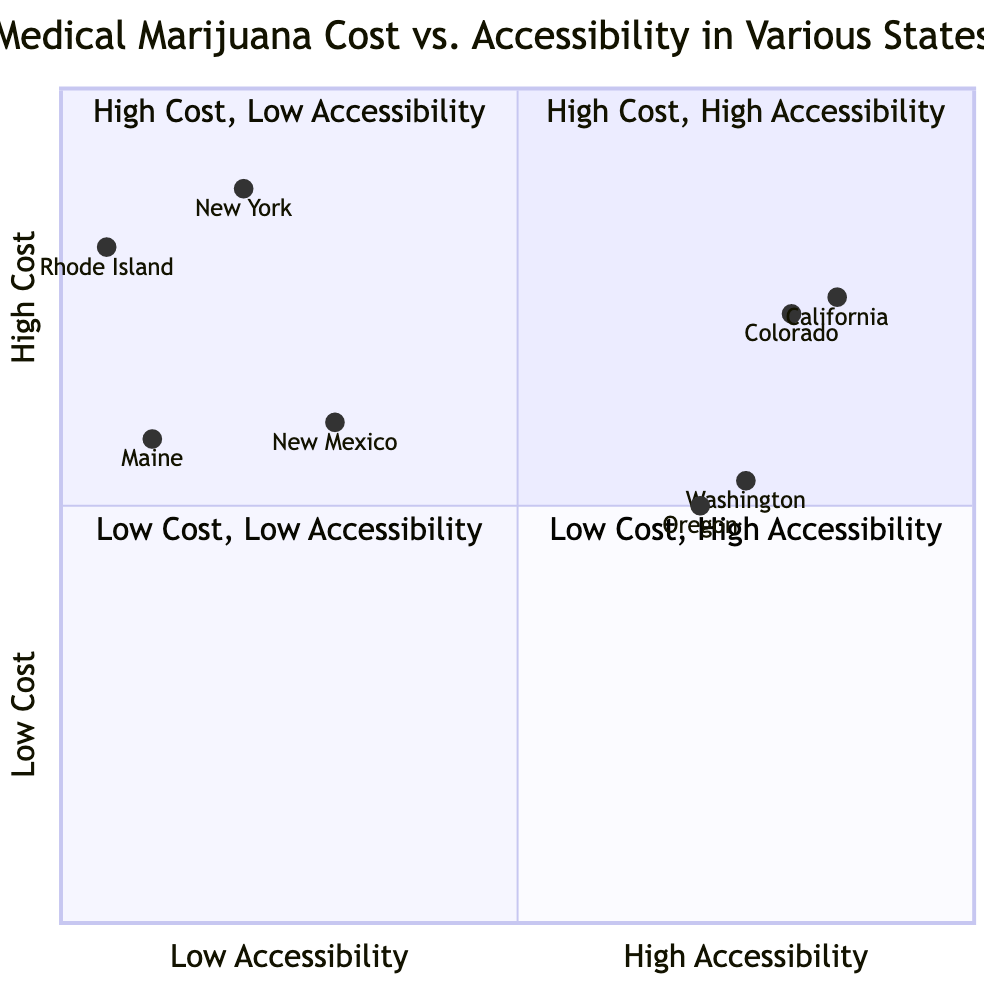What is the average monthly cost in California? The diagram lists California as having an average monthly cost of $300, as indicated within the description in the "High Cost, High Accessibility" quadrant.
Answer: $300 How many medical dispensaries are in Rhode Island? According to the information in the "High Cost, Low Accessibility" quadrant, Rhode Island has only 3 medical dispensaries.
Answer: 3 Which state has the highest average monthly cost? A comparison of the costs shows New York at $350, which is the highest figure listed in the "High Cost, Low Accessibility" quadrant.
Answer: New York What is the patient ease of access in Oregon? The diagram categorizes Oregon under "Low Cost, High Accessibility" and specifies that it has a high level of patient ease of access.
Answer: High How does the cost in Maine compare to the cost in New Mexico? Maine has an average monthly cost of $230, while New Mexico's average monthly cost is $240; therefore, Maine's cost is lower than New Mexico's.
Answer: Lower Which quadrant has the highest number of medical dispensaries? The "High Cost, High Accessibility" quadrant contains California with 1700 dispensaries and Colorado with 1200, making this quadrant the one with the highest number of dispensaries combined.
Answer: High Cost, High Accessibility Which states have low accessibility? The states categorized with low accessibility are New York, Rhode Island, Maine, and New Mexico, as seen in the different quadrants.
Answer: New York, Rhode Island, Maine, New Mexico What is the insurance coverage in Oregon? The description in the "Low Cost, High Accessibility" quadrant notes that Oregon has "Partial" insurance coverage for medical marijuana costs.
Answer: Partial How many medical dispensaries are in Washington? Washington has 600 medical dispensaries, which is provided in the "Low Cost, High Accessibility" quadrant section.
Answer: 600 